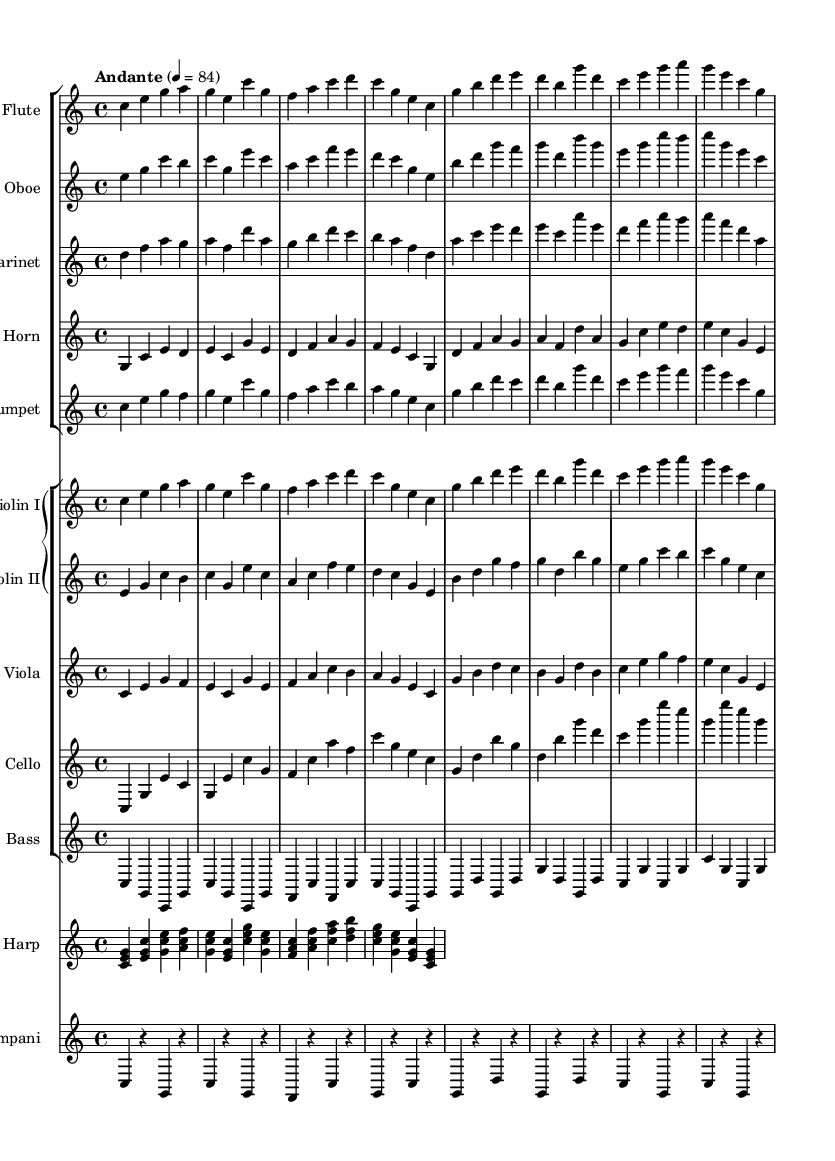What is the key signature of this music? The key signature is C major, which has no sharps or flats.
Answer: C major What is the time signature of this music? The time signature is indicated as 4/4, meaning there are four beats in each measure.
Answer: 4/4 What is the tempo marking for this music? The tempo marking “Andante” suggests a moderate walking pace, with a metronome mark of 84 beats per minute.
Answer: Andante How many instruments are featured in the orchestration? The score includes a total of 12 distinct instruments arranged in various groups.
Answer: 12 Which instrument plays the highest notes in this score? The flute typically plays the highest notes compared to the other instruments given in the score.
Answer: Flute What is the role of the timpani in this music? The timpani provides rhythmic and dynamic support, creating a dramatic effect with its low pitches.
Answer: Rhythmic support How does this orchestral score contribute to the theme of inclusive design in documentaries? The uplifting orchestral elements contribute to an inspiring atmosphere that aligns with messages of inclusivity and collaboration often portrayed in such documentaries.
Answer: Inspiring atmosphere 